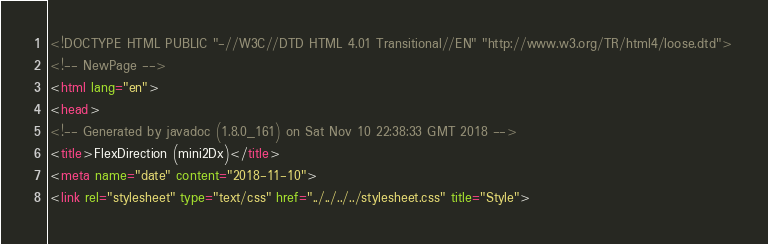Convert code to text. <code><loc_0><loc_0><loc_500><loc_500><_HTML_><!DOCTYPE HTML PUBLIC "-//W3C//DTD HTML 4.01 Transitional//EN" "http://www.w3.org/TR/html4/loose.dtd">
<!-- NewPage -->
<html lang="en">
<head>
<!-- Generated by javadoc (1.8.0_161) on Sat Nov 10 22:38:33 GMT 2018 -->
<title>FlexDirection (mini2Dx)</title>
<meta name="date" content="2018-11-10">
<link rel="stylesheet" type="text/css" href="../../../../stylesheet.css" title="Style"></code> 